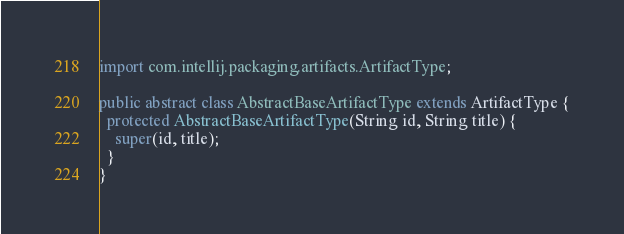Convert code to text. <code><loc_0><loc_0><loc_500><loc_500><_Java_>
import com.intellij.packaging.artifacts.ArtifactType;

public abstract class AbstractBaseArtifactType extends ArtifactType {
  protected AbstractBaseArtifactType(String id, String title) {
    super(id, title);
  }
}
</code> 